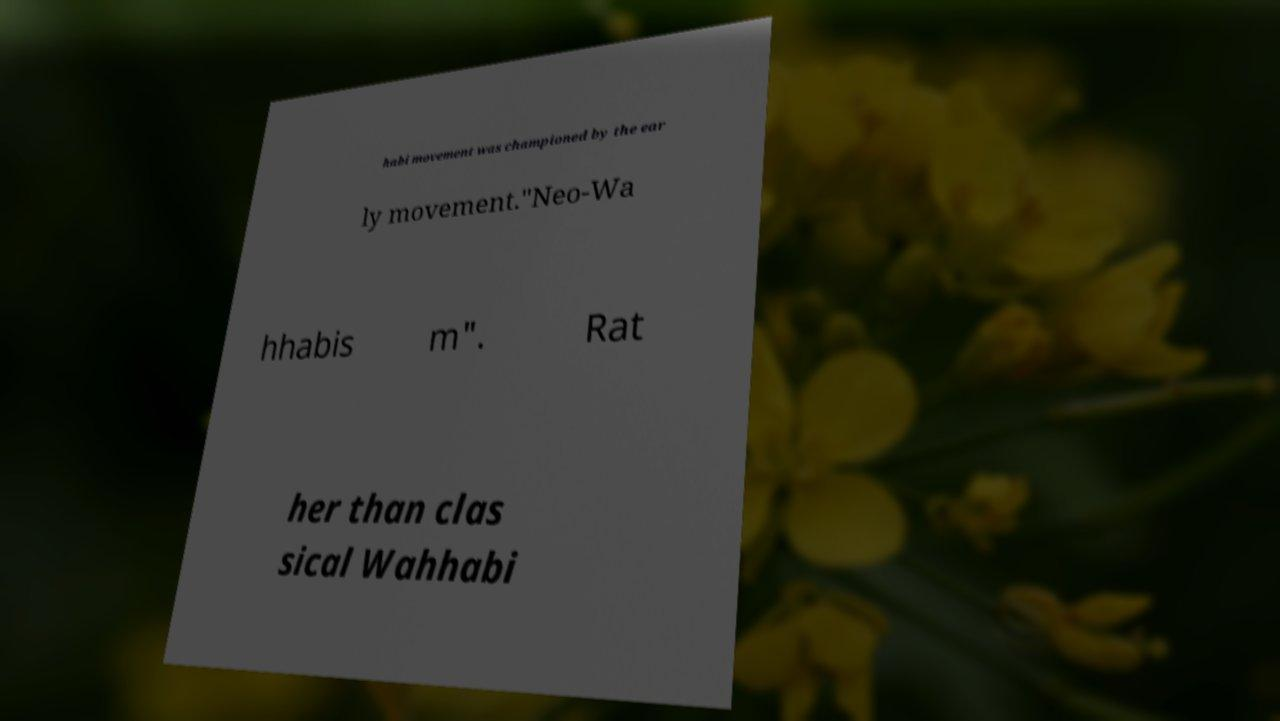Please read and relay the text visible in this image. What does it say? habi movement was championed by the ear ly movement."Neo-Wa hhabis m". Rat her than clas sical Wahhabi 